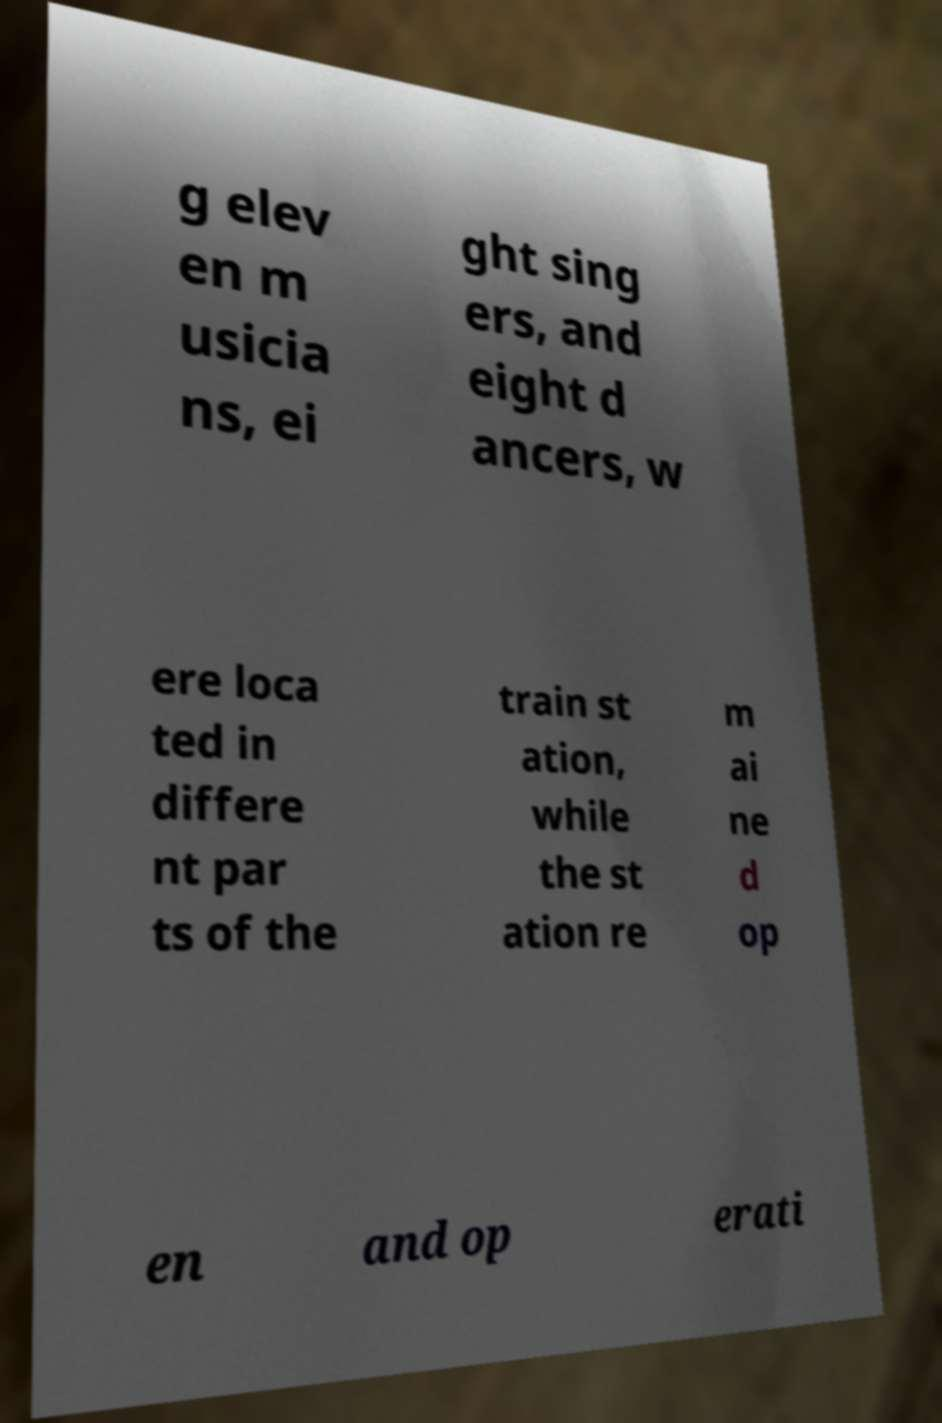What messages or text are displayed in this image? I need them in a readable, typed format. g elev en m usicia ns, ei ght sing ers, and eight d ancers, w ere loca ted in differe nt par ts of the train st ation, while the st ation re m ai ne d op en and op erati 